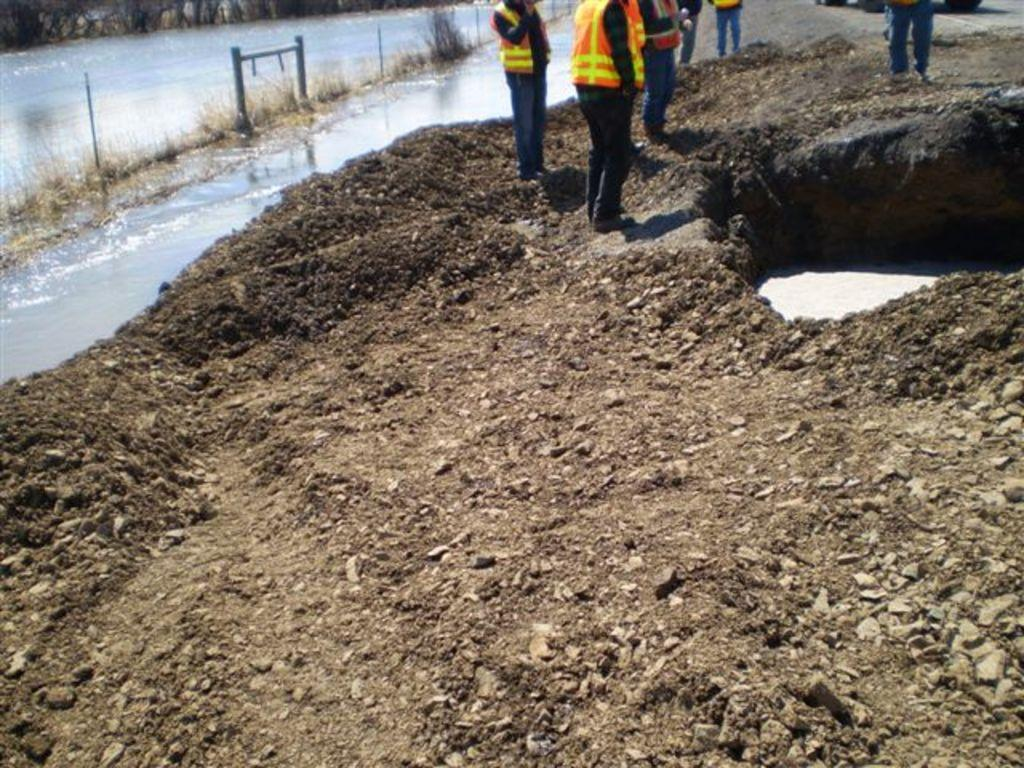How many people are in the image? There are people in the image, but the exact number is not specified. What are the people wearing in the image? The people are wearing life jackets in the image. What type of terrain is visible in the image? There is grass, water, and rocks visible in the image. Are there any safety items present in the image? Yes, there are life jackets in the image. What other objects can be seen in the image? There are other objects in the image, but their specific nature is not mentioned. How many apples are being used as a net in the image? There are no apples or nets present in the image. What type of army is depicted in the image? There is no army depicted in the image. 